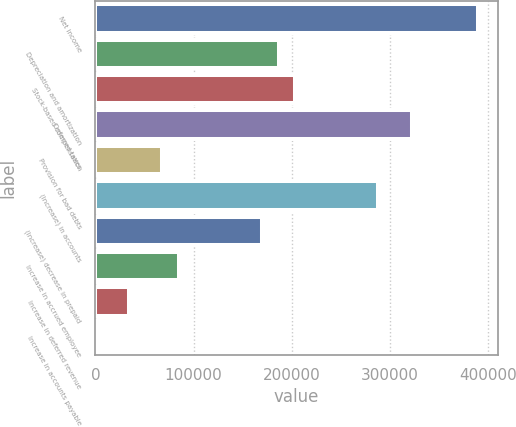Convert chart to OTSL. <chart><loc_0><loc_0><loc_500><loc_500><bar_chart><fcel>Net income<fcel>Depreciation and amortization<fcel>Stock-based compensation<fcel>Deferred taxes<fcel>Provision for bad debts<fcel>(Increase) in accounts<fcel>(Increase) decrease in prepaid<fcel>Increase in accrued employee<fcel>Increase in deferred revenue<fcel>Increase in accounts payable<nl><fcel>389895<fcel>186564<fcel>203508<fcel>322118<fcel>67954.8<fcel>288229<fcel>169620<fcel>84899<fcel>34066.4<fcel>178<nl></chart> 